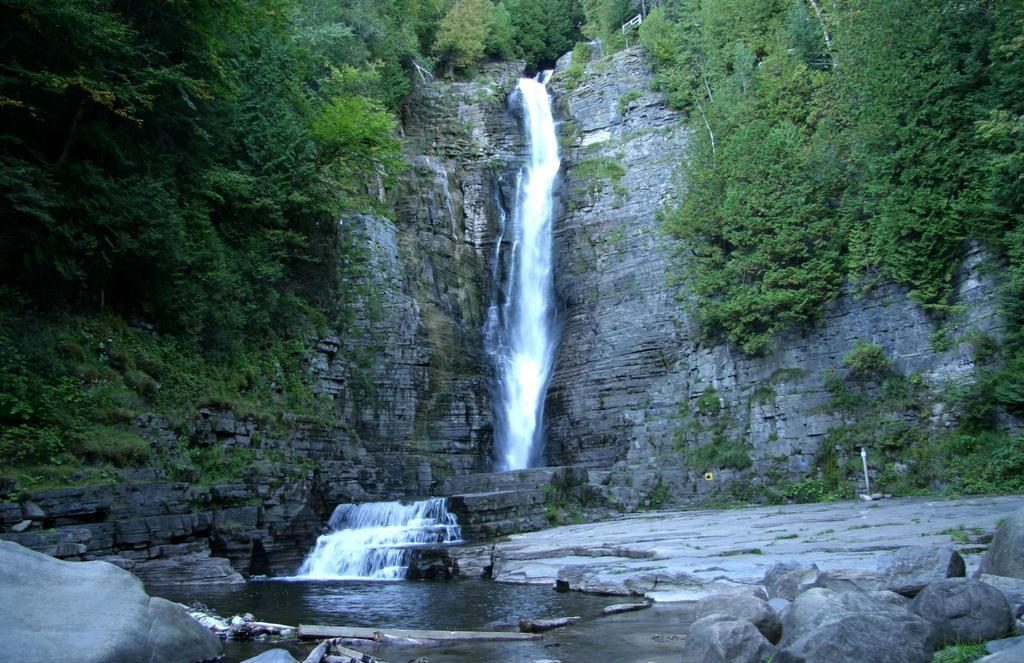How would you summarize this image in a sentence or two? In the foreground of the picture there are rocks, plants, wooden logs and water. At the top there are trees, plants, hill and a waterfall. 